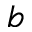Convert formula to latex. <formula><loc_0><loc_0><loc_500><loc_500>b</formula> 